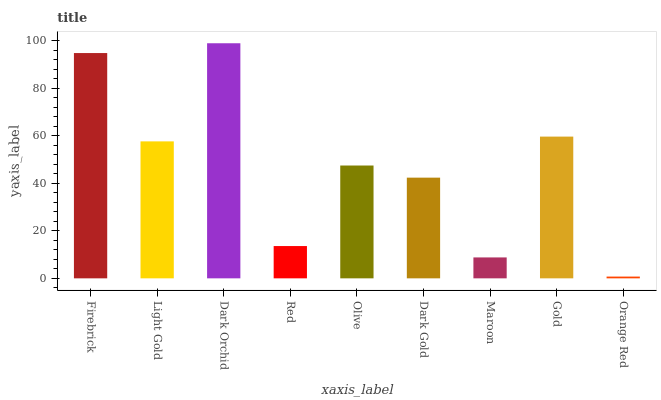Is Orange Red the minimum?
Answer yes or no. Yes. Is Dark Orchid the maximum?
Answer yes or no. Yes. Is Light Gold the minimum?
Answer yes or no. No. Is Light Gold the maximum?
Answer yes or no. No. Is Firebrick greater than Light Gold?
Answer yes or no. Yes. Is Light Gold less than Firebrick?
Answer yes or no. Yes. Is Light Gold greater than Firebrick?
Answer yes or no. No. Is Firebrick less than Light Gold?
Answer yes or no. No. Is Olive the high median?
Answer yes or no. Yes. Is Olive the low median?
Answer yes or no. Yes. Is Orange Red the high median?
Answer yes or no. No. Is Light Gold the low median?
Answer yes or no. No. 